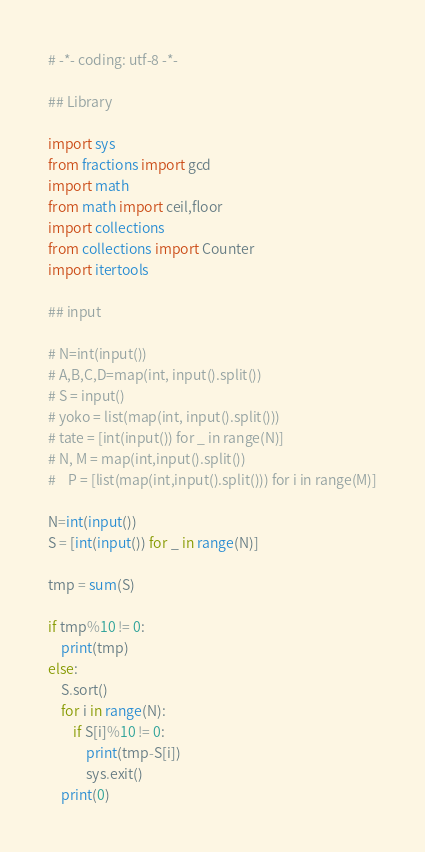Convert code to text. <code><loc_0><loc_0><loc_500><loc_500><_Python_># -*- coding: utf-8 -*-
 
## Library
 
import sys
from fractions import gcd
import math
from math import ceil,floor
import collections
from collections import Counter
import itertools

## input
 
# N=int(input())
# A,B,C,D=map(int, input().split())
# S = input()
# yoko = list(map(int, input().split()))
# tate = [int(input()) for _ in range(N)]
# N, M = map(int,input().split()) 
#    P = [list(map(int,input().split())) for i in range(M)]
 
N=int(input())
S = [int(input()) for _ in range(N)]

tmp = sum(S)

if tmp%10 != 0:
    print(tmp)
else:
    S.sort()
    for i in range(N):
        if S[i]%10 != 0:
            print(tmp-S[i])
            sys.exit()
    print(0)</code> 